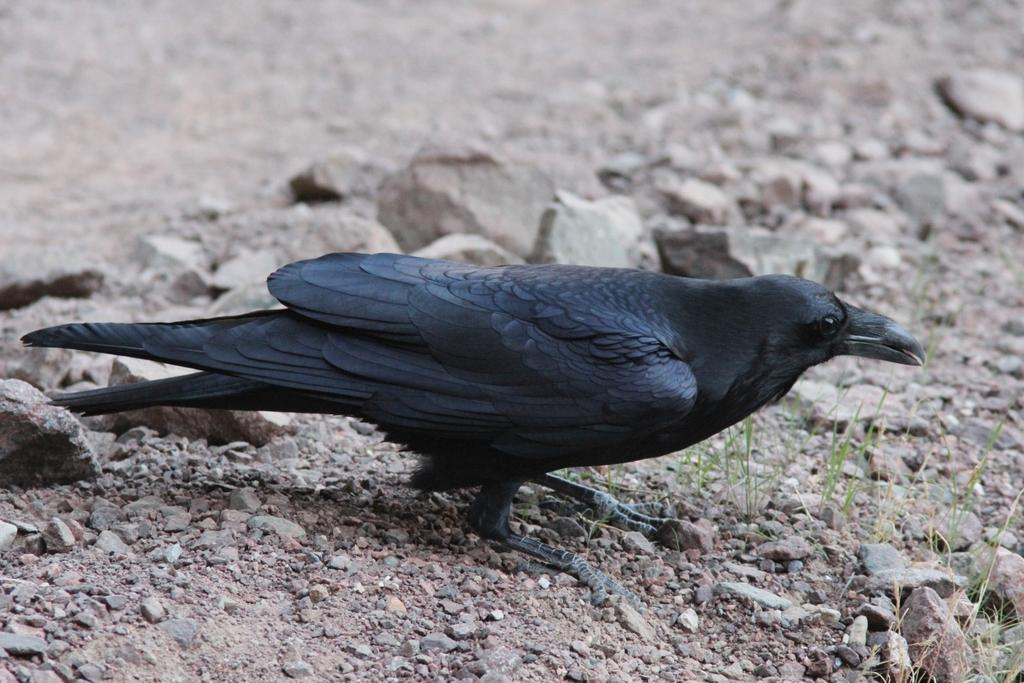What type of animal is in the image? There is a bird in the image. What color is the bird? The bird is gray in color. What can be seen in the background of the image? There are stones visible in the background of the image. What type of locket is the bird holding in the image? There is no locket present in the image; the bird is not holding anything. 